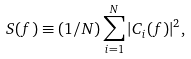Convert formula to latex. <formula><loc_0><loc_0><loc_500><loc_500>S ( f ) \equiv ( 1 / N ) \sum _ { i = 1 } ^ { N } | C _ { i } ( f ) | ^ { 2 } ,</formula> 